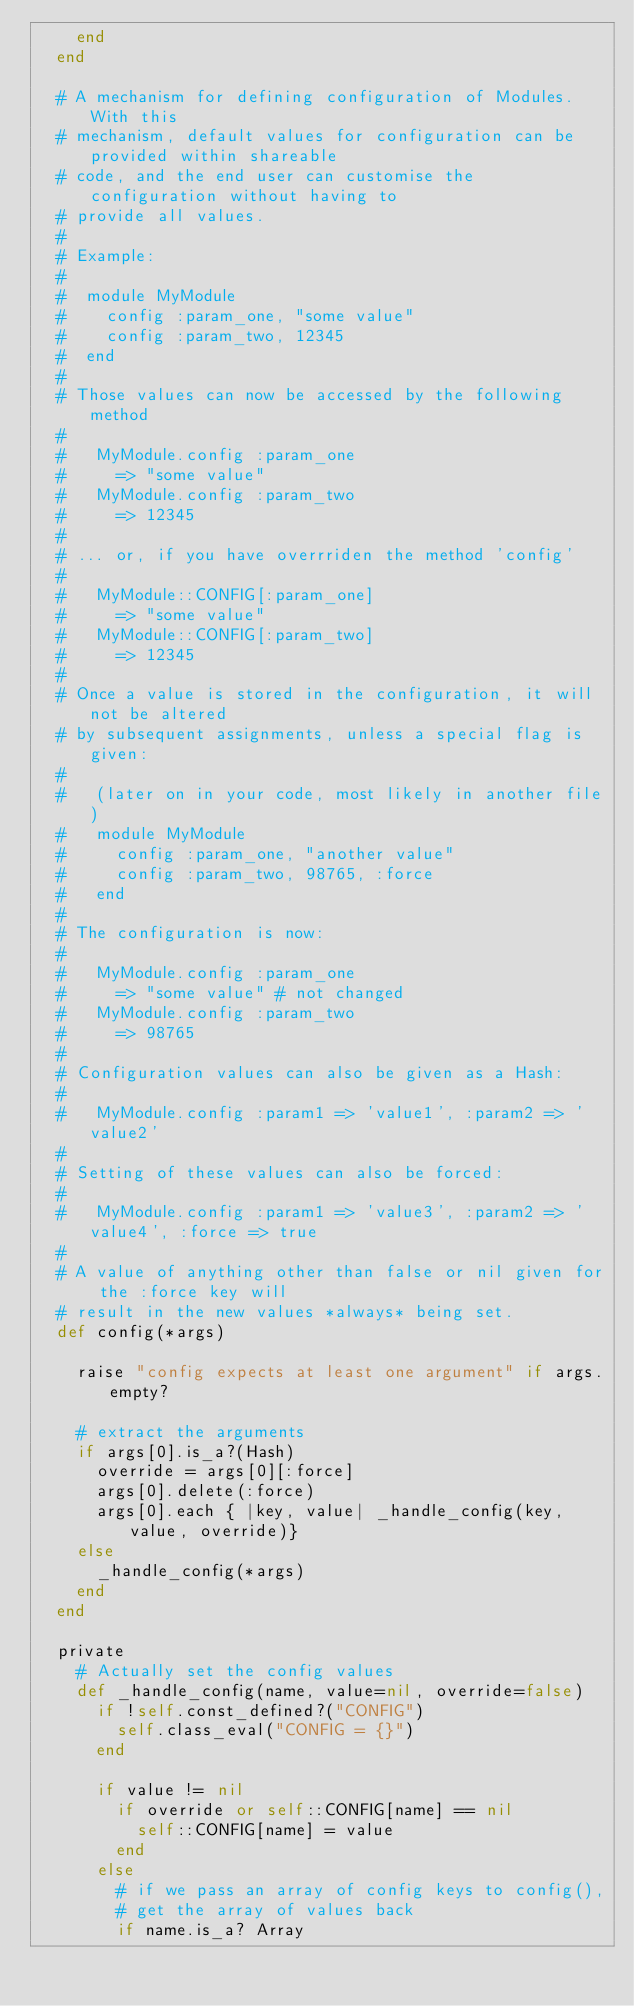<code> <loc_0><loc_0><loc_500><loc_500><_Ruby_>    end
  end
  
  # A mechanism for defining configuration of Modules. With this
  # mechanism, default values for configuration can be provided within shareable
  # code, and the end user can customise the configuration without having to
  # provide all values.
  #
  # Example:
  #
  #  module MyModule
  #    config :param_one, "some value"
  #    config :param_two, 12345
  #  end
  #
  # Those values can now be accessed by the following method
  #
  #   MyModule.config :param_one  
  #     => "some value"
  #   MyModule.config :param_two  
  #     => 12345
  #
  # ... or, if you have overrriden the method 'config'
  #
  #   MyModule::CONFIG[:param_one]  
  #     => "some value"
  #   MyModule::CONFIG[:param_two]  
  #     => 12345
  #
  # Once a value is stored in the configuration, it will not be altered
  # by subsequent assignments, unless a special flag is given:
  #
  #   (later on in your code, most likely in another file)
  #   module MyModule
  #     config :param_one, "another value"
  #     config :param_two, 98765, :force
  #   end
  #
  # The configuration is now:
  #
  #   MyModule.config :param_one  
  #     => "some value" # not changed
  #   MyModule.config :param_two  
  #     => 98765
  #
  # Configuration values can also be given as a Hash:
  #
  #   MyModule.config :param1 => 'value1', :param2 => 'value2'
  #
  # Setting of these values can also be forced:
  #
  #   MyModule.config :param1 => 'value3', :param2 => 'value4', :force => true
  #
  # A value of anything other than false or nil given for the :force key will
  # result in the new values *always* being set.
  def config(*args)
    
    raise "config expects at least one argument" if args.empty?
    
    # extract the arguments
    if args[0].is_a?(Hash)
      override = args[0][:force]
      args[0].delete(:force)
      args[0].each { |key, value| _handle_config(key, value, override)}
    else
      _handle_config(*args)
    end
  end
  
  private
    # Actually set the config values
    def _handle_config(name, value=nil, override=false)
      if !self.const_defined?("CONFIG")
        self.class_eval("CONFIG = {}")
      end
    
      if value != nil
        if override or self::CONFIG[name] == nil
          self::CONFIG[name] = value 
        end
      else
        # if we pass an array of config keys to config(),
        # get the array of values back
        if name.is_a? Array</code> 